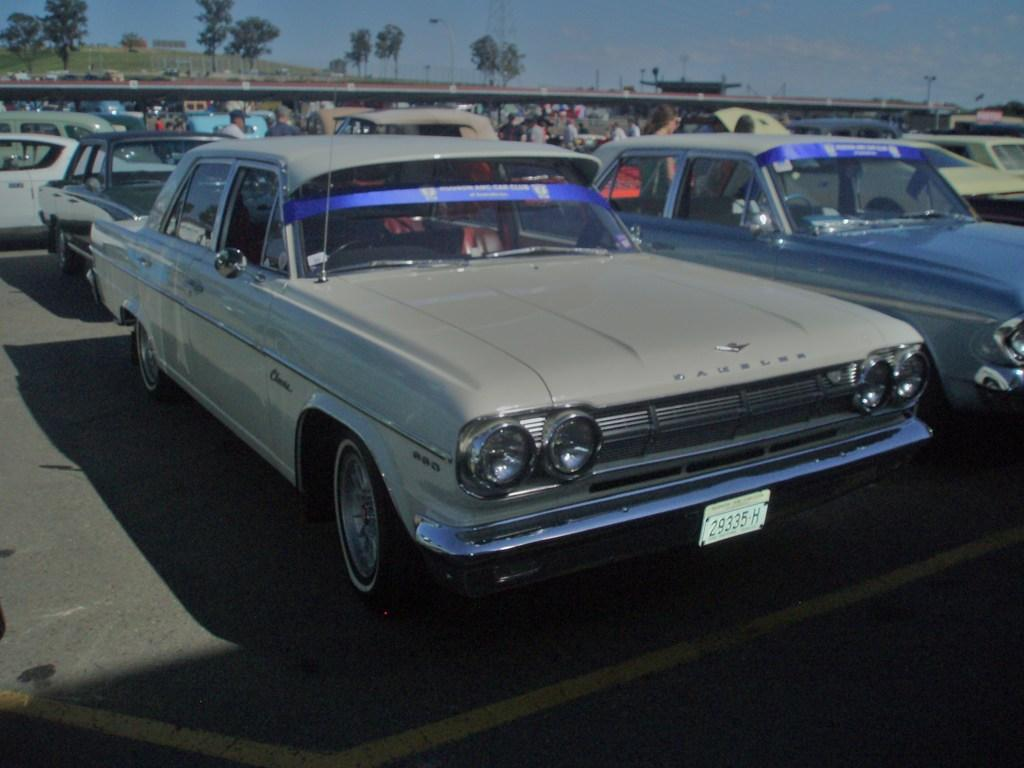<image>
Give a short and clear explanation of the subsequent image. a license plate with 29335 H on it 